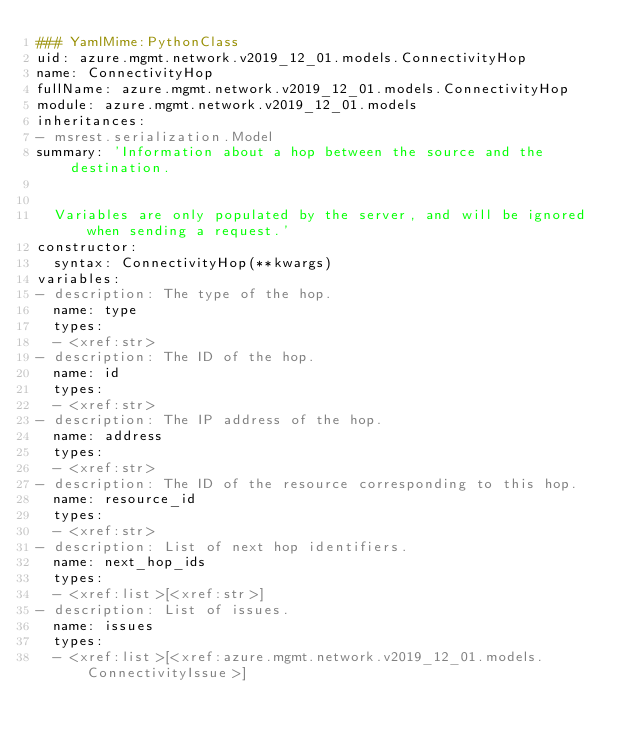Convert code to text. <code><loc_0><loc_0><loc_500><loc_500><_YAML_>### YamlMime:PythonClass
uid: azure.mgmt.network.v2019_12_01.models.ConnectivityHop
name: ConnectivityHop
fullName: azure.mgmt.network.v2019_12_01.models.ConnectivityHop
module: azure.mgmt.network.v2019_12_01.models
inheritances:
- msrest.serialization.Model
summary: 'Information about a hop between the source and the destination.


  Variables are only populated by the server, and will be ignored when sending a request.'
constructor:
  syntax: ConnectivityHop(**kwargs)
variables:
- description: The type of the hop.
  name: type
  types:
  - <xref:str>
- description: The ID of the hop.
  name: id
  types:
  - <xref:str>
- description: The IP address of the hop.
  name: address
  types:
  - <xref:str>
- description: The ID of the resource corresponding to this hop.
  name: resource_id
  types:
  - <xref:str>
- description: List of next hop identifiers.
  name: next_hop_ids
  types:
  - <xref:list>[<xref:str>]
- description: List of issues.
  name: issues
  types:
  - <xref:list>[<xref:azure.mgmt.network.v2019_12_01.models.ConnectivityIssue>]
</code> 